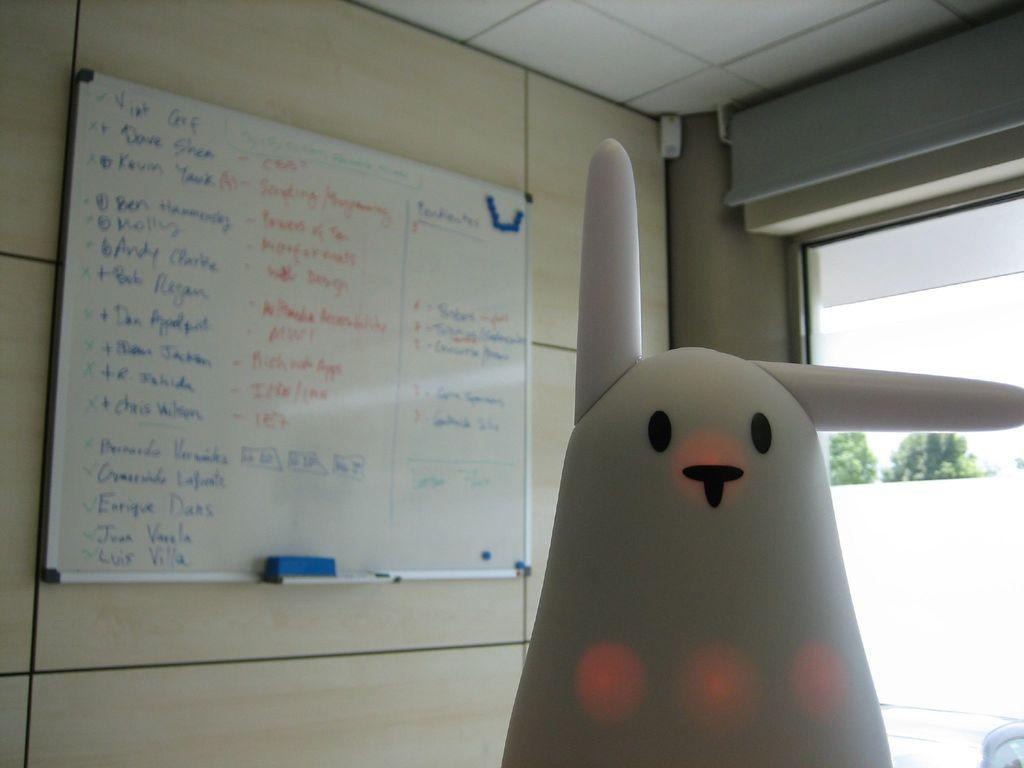What object in the image is likely meant for play or entertainment? There is a toy in the image. What is written or displayed on the board in the image? There is a board with writing in the image. What is the purpose of the duster on the board? The duster on the board is likely meant for cleaning or wiping the board. What type of natural scenery can be seen on the right side of the image? There are trees on the right side of the image. What feature in the image might allow for natural light or a view of the outdoors? There is a window in the image. What type of button can be seen on the stage in the image? There is no stage or button present in the image. What place is depicted in the image? The image does not depict a specific place; it contains a toy, a board with writing, a duster, trees, and a window. 